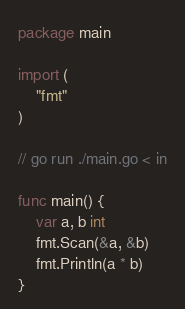Convert code to text. <code><loc_0><loc_0><loc_500><loc_500><_Go_>package main

import (
	"fmt"
)

// go run ./main.go < in

func main() {
	var a, b int
	fmt.Scan(&a, &b)
	fmt.Println(a * b)
}
</code> 